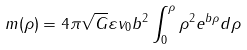Convert formula to latex. <formula><loc_0><loc_0><loc_500><loc_500>m ( \rho ) = 4 \pi \sqrt { G } \varepsilon v _ { 0 } b ^ { 2 } \int _ { 0 } ^ { \rho } \rho ^ { 2 } e ^ { b \rho } d \rho</formula> 